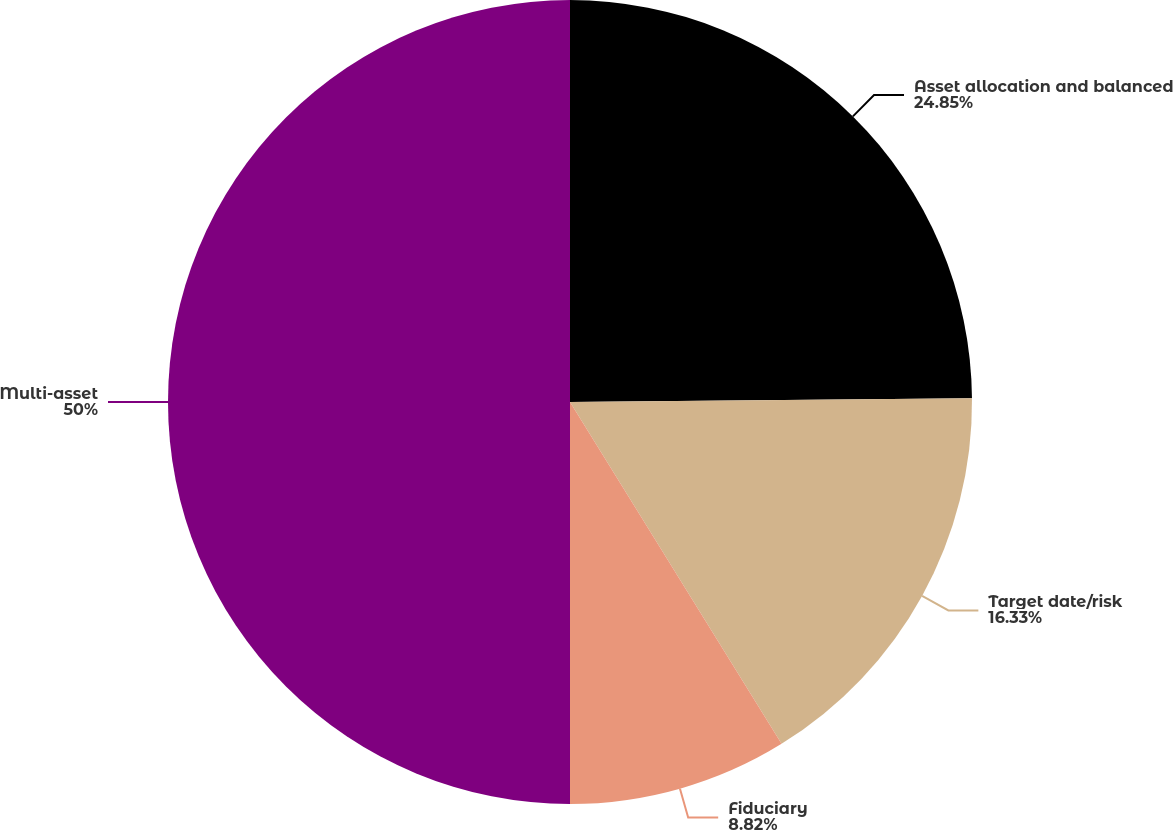Convert chart to OTSL. <chart><loc_0><loc_0><loc_500><loc_500><pie_chart><fcel>Asset allocation and balanced<fcel>Target date/risk<fcel>Fiduciary<fcel>Multi-asset<nl><fcel>24.85%<fcel>16.33%<fcel>8.82%<fcel>50.0%<nl></chart> 